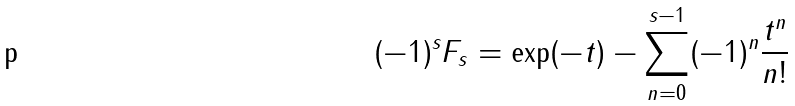Convert formula to latex. <formula><loc_0><loc_0><loc_500><loc_500>( - 1 ) ^ { s } F _ { s } = \exp ( - t ) - \sum _ { n = 0 } ^ { s - 1 } ( - 1 ) ^ { n } \frac { t ^ { n } } { n ! }</formula> 